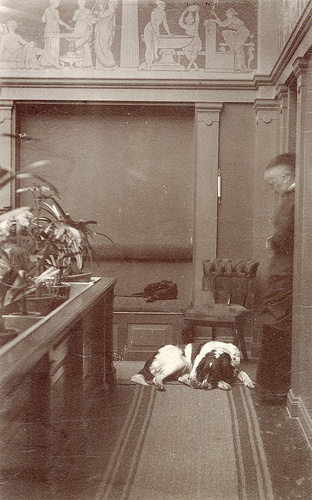Describe the objects in this image and their specific colors. I can see people in lightgray, maroon, and gray tones, chair in lightgray, gray, and maroon tones, dog in lightgray, ivory, gray, maroon, and darkgray tones, chair in lightgray, maroon, brown, and gray tones, and potted plant in lightgray, gray, and brown tones in this image. 